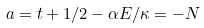<formula> <loc_0><loc_0><loc_500><loc_500>a = t + 1 / 2 - \alpha E / \kappa = - N</formula> 